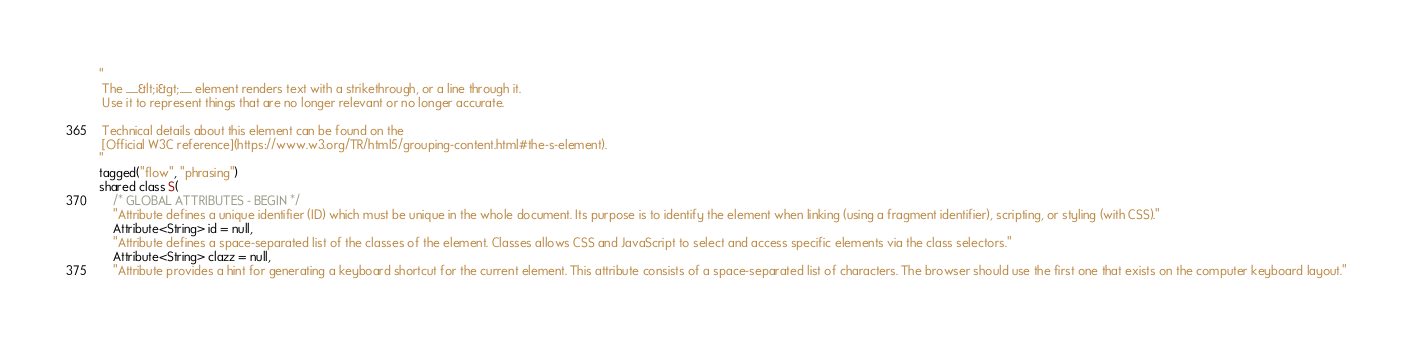<code> <loc_0><loc_0><loc_500><loc_500><_Ceylon_>"
 The __&lt;i&gt;__ element renders text with a strikethrough, or a line through it. 
 Use it to represent things that are no longer relevant or no longer accurate.
 
 Technical details about this element can be found on the
 [Official W3C reference](https://www.w3.org/TR/html5/grouping-content.html#the-s-element).
"
tagged("flow", "phrasing")
shared class S(
    /* GLOBAL ATTRIBUTES - BEGIN */
    "Attribute defines a unique identifier (ID) which must be unique in the whole document. Its purpose is to identify the element when linking (using a fragment identifier), scripting, or styling (with CSS)."
    Attribute<String> id = null,
    "Attribute defines a space-separated list of the classes of the element. Classes allows CSS and JavaScript to select and access specific elements via the class selectors."
    Attribute<String> clazz = null,
    "Attribute provides a hint for generating a keyboard shortcut for the current element. This attribute consists of a space-separated list of characters. The browser should use the first one that exists on the computer keyboard layout."</code> 